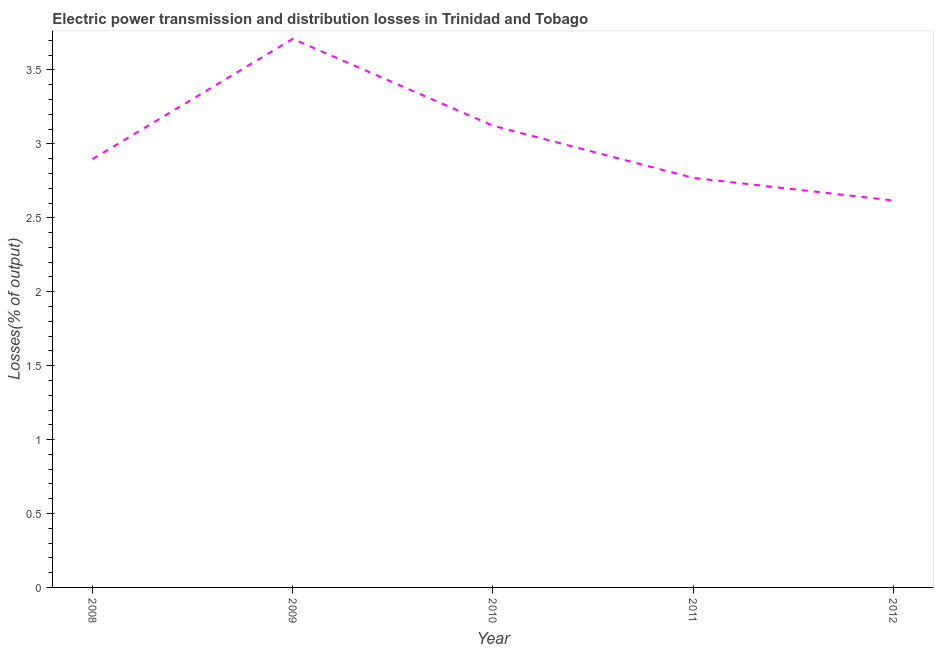What is the electric power transmission and distribution losses in 2010?
Give a very brief answer. 3.12. Across all years, what is the maximum electric power transmission and distribution losses?
Your answer should be compact. 3.71. Across all years, what is the minimum electric power transmission and distribution losses?
Ensure brevity in your answer.  2.62. In which year was the electric power transmission and distribution losses maximum?
Give a very brief answer. 2009. In which year was the electric power transmission and distribution losses minimum?
Offer a terse response. 2012. What is the sum of the electric power transmission and distribution losses?
Ensure brevity in your answer.  15.12. What is the difference between the electric power transmission and distribution losses in 2008 and 2012?
Your answer should be compact. 0.28. What is the average electric power transmission and distribution losses per year?
Your answer should be compact. 3.02. What is the median electric power transmission and distribution losses?
Provide a short and direct response. 2.9. In how many years, is the electric power transmission and distribution losses greater than 3.3 %?
Make the answer very short. 1. Do a majority of the years between 2010 and 2012 (inclusive) have electric power transmission and distribution losses greater than 1.3 %?
Your answer should be very brief. Yes. What is the ratio of the electric power transmission and distribution losses in 2009 to that in 2012?
Provide a short and direct response. 1.42. What is the difference between the highest and the second highest electric power transmission and distribution losses?
Your response must be concise. 0.59. What is the difference between the highest and the lowest electric power transmission and distribution losses?
Your answer should be very brief. 1.09. In how many years, is the electric power transmission and distribution losses greater than the average electric power transmission and distribution losses taken over all years?
Offer a terse response. 2. Does the electric power transmission and distribution losses monotonically increase over the years?
Provide a short and direct response. No. Does the graph contain any zero values?
Your answer should be compact. No. Does the graph contain grids?
Offer a terse response. No. What is the title of the graph?
Offer a very short reply. Electric power transmission and distribution losses in Trinidad and Tobago. What is the label or title of the X-axis?
Offer a very short reply. Year. What is the label or title of the Y-axis?
Offer a terse response. Losses(% of output). What is the Losses(% of output) of 2008?
Offer a terse response. 2.9. What is the Losses(% of output) of 2009?
Keep it short and to the point. 3.71. What is the Losses(% of output) in 2010?
Ensure brevity in your answer.  3.12. What is the Losses(% of output) in 2011?
Give a very brief answer. 2.77. What is the Losses(% of output) of 2012?
Give a very brief answer. 2.62. What is the difference between the Losses(% of output) in 2008 and 2009?
Make the answer very short. -0.81. What is the difference between the Losses(% of output) in 2008 and 2010?
Keep it short and to the point. -0.23. What is the difference between the Losses(% of output) in 2008 and 2011?
Keep it short and to the point. 0.13. What is the difference between the Losses(% of output) in 2008 and 2012?
Your answer should be very brief. 0.28. What is the difference between the Losses(% of output) in 2009 and 2010?
Your answer should be very brief. 0.59. What is the difference between the Losses(% of output) in 2009 and 2011?
Make the answer very short. 0.94. What is the difference between the Losses(% of output) in 2009 and 2012?
Give a very brief answer. 1.09. What is the difference between the Losses(% of output) in 2010 and 2011?
Provide a short and direct response. 0.35. What is the difference between the Losses(% of output) in 2010 and 2012?
Provide a short and direct response. 0.51. What is the difference between the Losses(% of output) in 2011 and 2012?
Provide a short and direct response. 0.15. What is the ratio of the Losses(% of output) in 2008 to that in 2009?
Your answer should be compact. 0.78. What is the ratio of the Losses(% of output) in 2008 to that in 2010?
Provide a short and direct response. 0.93. What is the ratio of the Losses(% of output) in 2008 to that in 2011?
Keep it short and to the point. 1.05. What is the ratio of the Losses(% of output) in 2008 to that in 2012?
Make the answer very short. 1.11. What is the ratio of the Losses(% of output) in 2009 to that in 2010?
Provide a succinct answer. 1.19. What is the ratio of the Losses(% of output) in 2009 to that in 2011?
Ensure brevity in your answer.  1.34. What is the ratio of the Losses(% of output) in 2009 to that in 2012?
Provide a succinct answer. 1.42. What is the ratio of the Losses(% of output) in 2010 to that in 2011?
Make the answer very short. 1.13. What is the ratio of the Losses(% of output) in 2010 to that in 2012?
Offer a very short reply. 1.19. What is the ratio of the Losses(% of output) in 2011 to that in 2012?
Offer a very short reply. 1.06. 